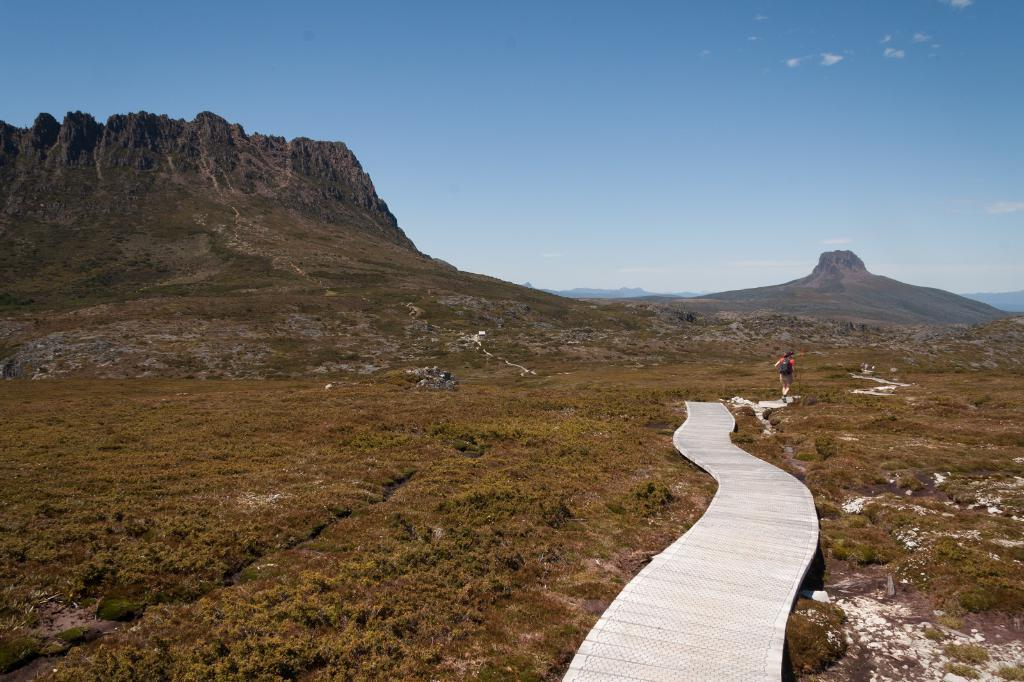What is in the foreground of the image? There is a path in the foreground of the image. What is the person in the image doing? A person is walking on the path. What type of terrain is visible on either side of the path? There is grassland on either side of the path. What can be seen in the background of the image? There are mountains and the sky visible in the background of the image. How many pets are visible in the image? There are no pets present in the image. What type of uncle is standing near the mountains in the image? There is no uncle present in the image. 